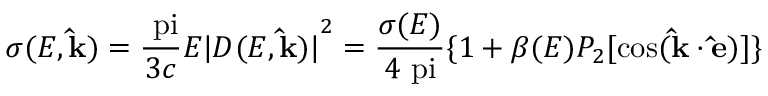<formula> <loc_0><loc_0><loc_500><loc_500>\sigma ( E , \hat { k } ) = \frac { \ p i } { 3 c } E { | D ( E , \hat { k } ) | } ^ { 2 } = \frac { \sigma ( E ) } { 4 \ p i } \{ 1 + \beta ( E ) P _ { 2 } [ { \cos } ( \hat { k } \cdot \hat { e } ) ] \}</formula> 